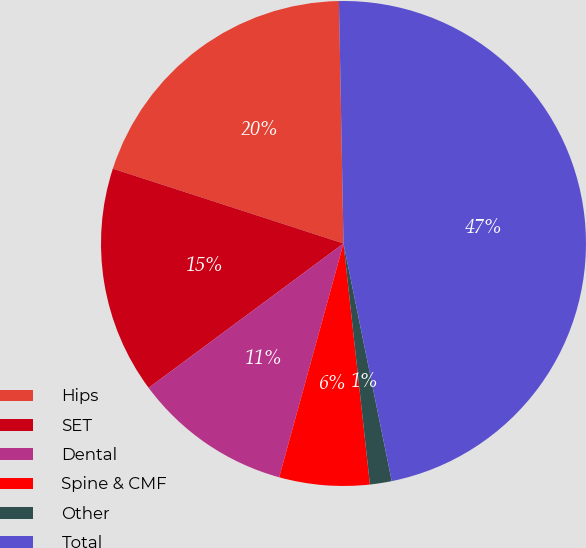Convert chart to OTSL. <chart><loc_0><loc_0><loc_500><loc_500><pie_chart><fcel>Hips<fcel>SET<fcel>Dental<fcel>Spine & CMF<fcel>Other<fcel>Total<nl><fcel>19.71%<fcel>15.14%<fcel>10.58%<fcel>6.01%<fcel>1.45%<fcel>47.11%<nl></chart> 